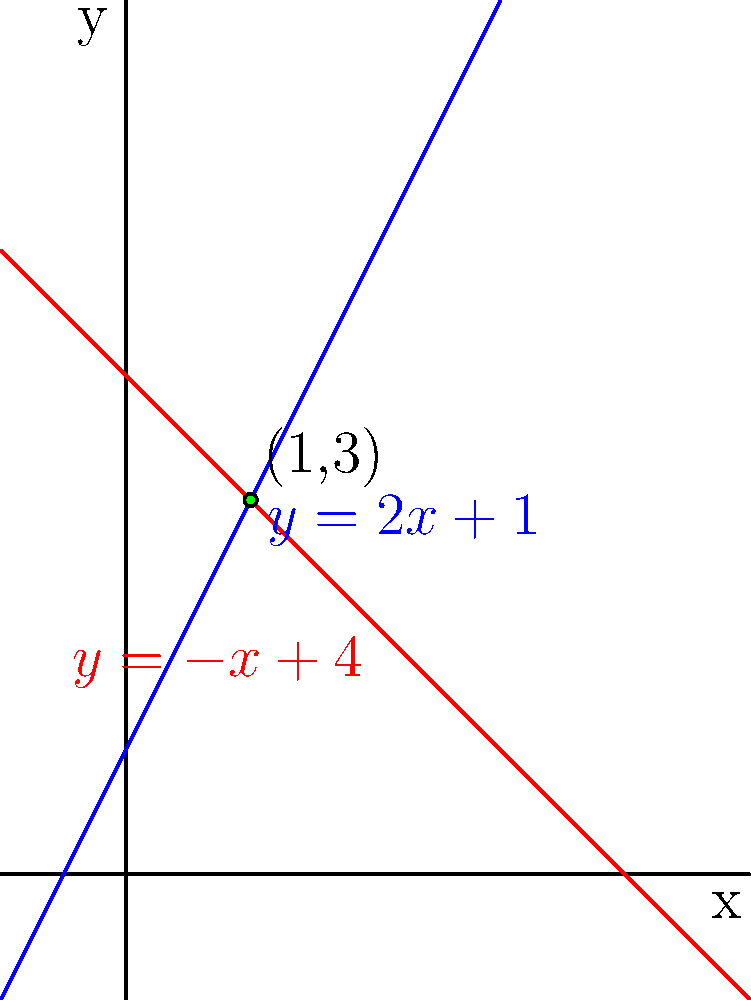As a supporter of Bobbi Ann Brady, you're helping to plan a community event. Two local businesses have offered to contribute funds based on the number of attendees. Company A's contribution is represented by the equation $y = 2x + 1$, and Company B's by $y = -x + 4$, where $x$ is the number of hundreds of attendees and $y$ is the contribution in thousands of dollars. At what number of attendees will both companies contribute the same amount, and what will that contribution be? To find the point where both companies contribute the same amount, we need to find the intersection of the two lines represented by their equations.

1) Set the equations equal to each other:
   $2x + 1 = -x + 4$

2) Solve for x:
   $2x + 1 = -x + 4$
   $3x = 3$
   $x = 1$

3) This means the lines intersect when there are 100 attendees (since x represents hundreds of attendees).

4) To find the contribution amount, substitute x = 1 into either equation:
   $y = 2(1) + 1 = 3$ or $y = -1 + 4 = 3$

5) The contribution amount is $3,000 (since y represents thousands of dollars).

Therefore, both companies will contribute the same amount when there are 100 attendees, and that contribution will be $3,000.
Answer: 100 attendees; $3,000 